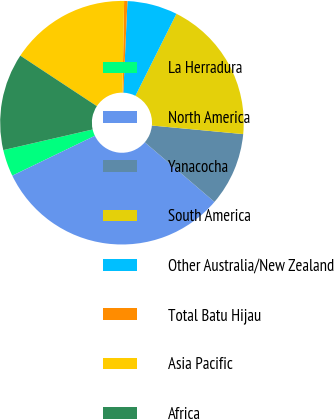Convert chart. <chart><loc_0><loc_0><loc_500><loc_500><pie_chart><fcel>La Herradura<fcel>North America<fcel>Yanacocha<fcel>South America<fcel>Other Australia/New Zealand<fcel>Total Batu Hijau<fcel>Asia Pacific<fcel>Africa<nl><fcel>3.55%<fcel>31.57%<fcel>9.78%<fcel>19.11%<fcel>6.66%<fcel>0.44%<fcel>16.0%<fcel>12.89%<nl></chart> 